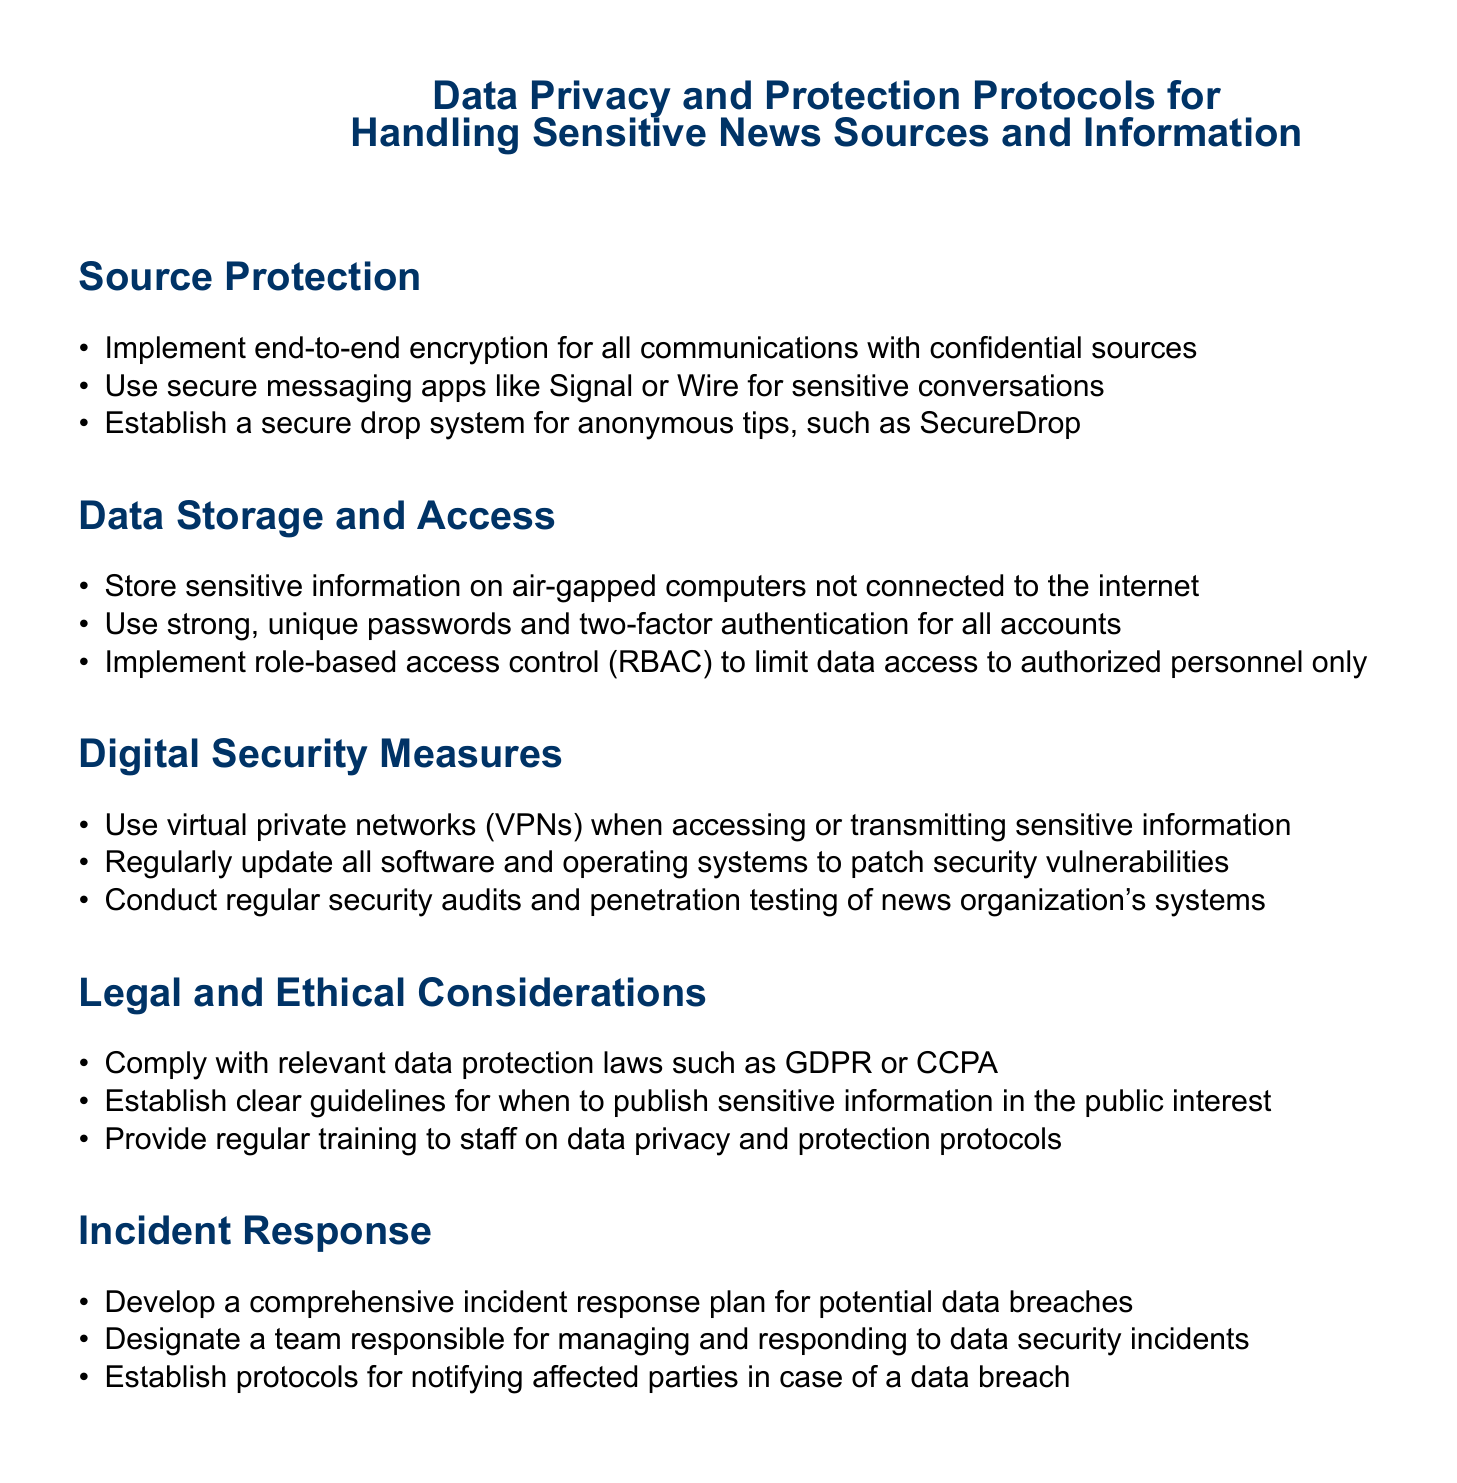What is the primary focus of the document? The document focuses on protocols for ensuring privacy and protection when handling sensitive news information and sources.
Answer: Data Privacy and Protection Protocols What communication methods are recommended for confidential sources? The document suggests using secure messaging apps like Signal or Wire for sensitive conversations.
Answer: Secure messaging apps What is the purpose of a secure drop system mentioned in the document? The secure drop system is established for receiving anonymous tips to protect the identity of sources.
Answer: Anonymous tips What type of access control is recommended for limiting data access? The document recommends implementing role-based access control (RBAC).
Answer: Role-based access control What should be used to access sensitive information remotely? The document advises using virtual private networks (VPNs) when accessing sensitive information.
Answer: Virtual private networks What training is suggested for staff in the document? The document specifies providing regular training to staff on data privacy and protection protocols.
Answer: Regular training How often should software and operating systems be updated? The document does not specify a precise frequency but emphasizes the need for regular updates to patch vulnerabilities.
Answer: Regularly What should a news organization develop for data breaches? The document states that a comprehensive incident response plan should be developed for potential data breaches.
Answer: Incident response plan Which data protection laws are mentioned in the document? The document mentions compliance with laws such as GDPR or CCPA.
Answer: GDPR or CCPA 